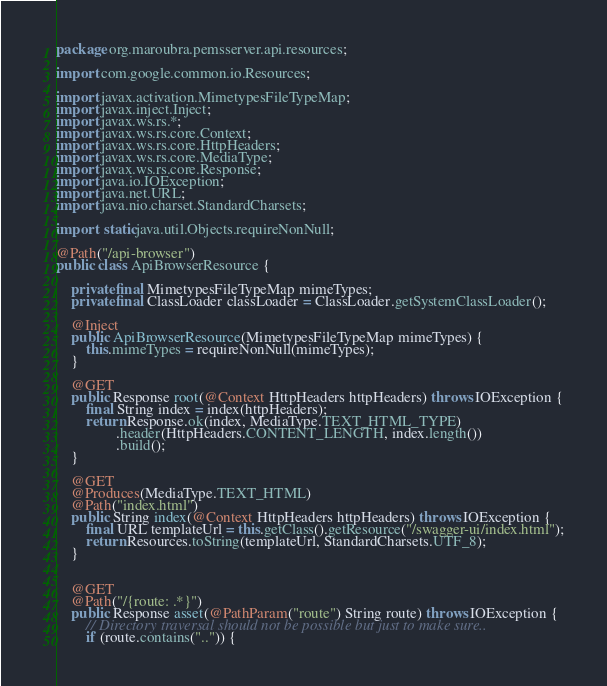Convert code to text. <code><loc_0><loc_0><loc_500><loc_500><_Java_>package org.maroubra.pemsserver.api.resources;

import com.google.common.io.Resources;

import javax.activation.MimetypesFileTypeMap;
import javax.inject.Inject;
import javax.ws.rs.*;
import javax.ws.rs.core.Context;
import javax.ws.rs.core.HttpHeaders;
import javax.ws.rs.core.MediaType;
import javax.ws.rs.core.Response;
import java.io.IOException;
import java.net.URL;
import java.nio.charset.StandardCharsets;

import static java.util.Objects.requireNonNull;

@Path("/api-browser")
public class ApiBrowserResource {

    private final MimetypesFileTypeMap mimeTypes;
    private final ClassLoader classLoader = ClassLoader.getSystemClassLoader();

    @Inject
    public ApiBrowserResource(MimetypesFileTypeMap mimeTypes) {
        this.mimeTypes = requireNonNull(mimeTypes);
    }

    @GET
    public Response root(@Context HttpHeaders httpHeaders) throws IOException {
        final String index = index(httpHeaders);
        return Response.ok(index, MediaType.TEXT_HTML_TYPE)
                .header(HttpHeaders.CONTENT_LENGTH, index.length())
                .build();
    }

    @GET
    @Produces(MediaType.TEXT_HTML)
    @Path("index.html")
    public String index(@Context HttpHeaders httpHeaders) throws IOException {
        final URL templateUrl = this.getClass().getResource("/swagger-ui/index.html");
        return Resources.toString(templateUrl, StandardCharsets.UTF_8);
    }


    @GET
    @Path("/{route: .*}")
    public Response asset(@PathParam("route") String route) throws IOException {
        // Directory traversal should not be possible but just to make sure..
        if (route.contains("..")) {</code> 